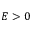Convert formula to latex. <formula><loc_0><loc_0><loc_500><loc_500>E > 0</formula> 